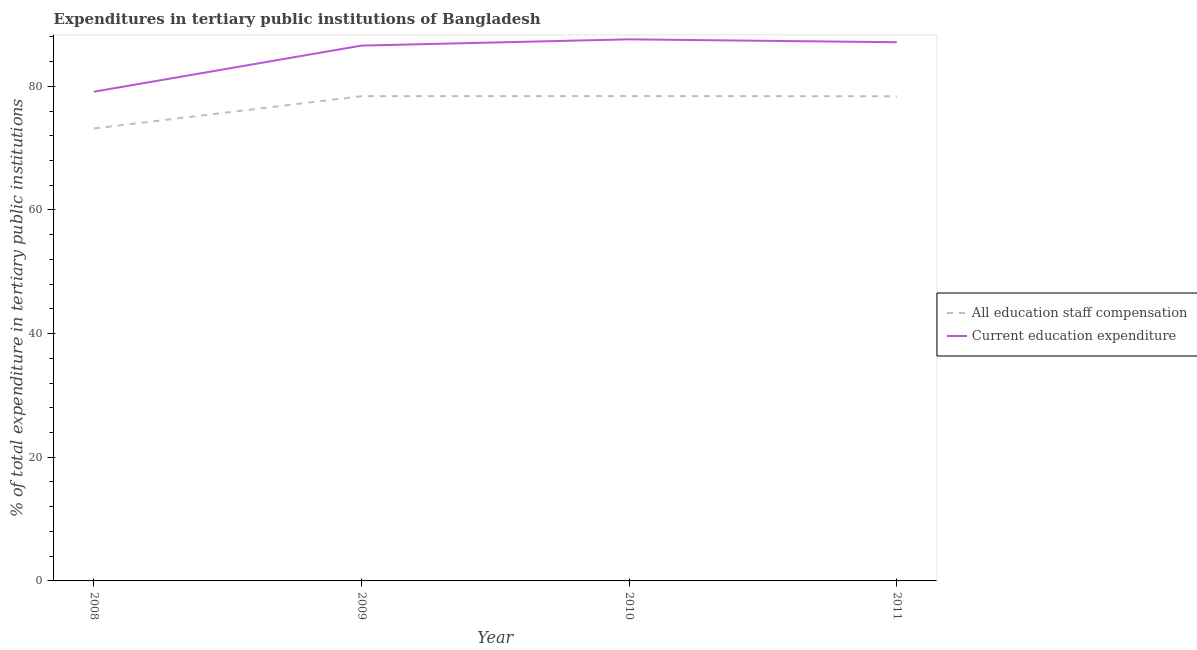How many different coloured lines are there?
Your answer should be very brief. 2. Does the line corresponding to expenditure in staff compensation intersect with the line corresponding to expenditure in education?
Keep it short and to the point. No. What is the expenditure in staff compensation in 2010?
Your answer should be very brief. 78.42. Across all years, what is the maximum expenditure in education?
Provide a succinct answer. 87.59. Across all years, what is the minimum expenditure in education?
Ensure brevity in your answer.  79.12. What is the total expenditure in education in the graph?
Give a very brief answer. 340.41. What is the difference between the expenditure in staff compensation in 2010 and that in 2011?
Your answer should be very brief. 0.04. What is the difference between the expenditure in staff compensation in 2011 and the expenditure in education in 2008?
Ensure brevity in your answer.  -0.74. What is the average expenditure in staff compensation per year?
Offer a very short reply. 77.09. In the year 2010, what is the difference between the expenditure in staff compensation and expenditure in education?
Provide a succinct answer. -9.17. In how many years, is the expenditure in staff compensation greater than 68 %?
Provide a succinct answer. 4. What is the ratio of the expenditure in staff compensation in 2008 to that in 2009?
Your response must be concise. 0.93. Is the expenditure in staff compensation in 2008 less than that in 2010?
Your response must be concise. Yes. What is the difference between the highest and the second highest expenditure in education?
Provide a succinct answer. 0.47. What is the difference between the highest and the lowest expenditure in staff compensation?
Make the answer very short. 5.25. In how many years, is the expenditure in staff compensation greater than the average expenditure in staff compensation taken over all years?
Your response must be concise. 3. Is the expenditure in education strictly greater than the expenditure in staff compensation over the years?
Ensure brevity in your answer.  Yes. How many years are there in the graph?
Your answer should be compact. 4. Does the graph contain grids?
Give a very brief answer. No. How are the legend labels stacked?
Keep it short and to the point. Vertical. What is the title of the graph?
Your answer should be compact. Expenditures in tertiary public institutions of Bangladesh. Does "Number of arrivals" appear as one of the legend labels in the graph?
Offer a terse response. No. What is the label or title of the X-axis?
Give a very brief answer. Year. What is the label or title of the Y-axis?
Provide a succinct answer. % of total expenditure in tertiary public institutions. What is the % of total expenditure in tertiary public institutions in All education staff compensation in 2008?
Provide a short and direct response. 73.17. What is the % of total expenditure in tertiary public institutions in Current education expenditure in 2008?
Make the answer very short. 79.12. What is the % of total expenditure in tertiary public institutions of All education staff compensation in 2009?
Your response must be concise. 78.4. What is the % of total expenditure in tertiary public institutions in Current education expenditure in 2009?
Ensure brevity in your answer.  86.58. What is the % of total expenditure in tertiary public institutions of All education staff compensation in 2010?
Your response must be concise. 78.42. What is the % of total expenditure in tertiary public institutions in Current education expenditure in 2010?
Your answer should be very brief. 87.59. What is the % of total expenditure in tertiary public institutions in All education staff compensation in 2011?
Offer a very short reply. 78.38. What is the % of total expenditure in tertiary public institutions in Current education expenditure in 2011?
Your response must be concise. 87.12. Across all years, what is the maximum % of total expenditure in tertiary public institutions of All education staff compensation?
Ensure brevity in your answer.  78.42. Across all years, what is the maximum % of total expenditure in tertiary public institutions of Current education expenditure?
Provide a succinct answer. 87.59. Across all years, what is the minimum % of total expenditure in tertiary public institutions of All education staff compensation?
Offer a very short reply. 73.17. Across all years, what is the minimum % of total expenditure in tertiary public institutions in Current education expenditure?
Provide a short and direct response. 79.12. What is the total % of total expenditure in tertiary public institutions in All education staff compensation in the graph?
Ensure brevity in your answer.  308.37. What is the total % of total expenditure in tertiary public institutions in Current education expenditure in the graph?
Ensure brevity in your answer.  340.41. What is the difference between the % of total expenditure in tertiary public institutions of All education staff compensation in 2008 and that in 2009?
Give a very brief answer. -5.23. What is the difference between the % of total expenditure in tertiary public institutions in Current education expenditure in 2008 and that in 2009?
Make the answer very short. -7.46. What is the difference between the % of total expenditure in tertiary public institutions in All education staff compensation in 2008 and that in 2010?
Provide a succinct answer. -5.25. What is the difference between the % of total expenditure in tertiary public institutions in Current education expenditure in 2008 and that in 2010?
Offer a very short reply. -8.47. What is the difference between the % of total expenditure in tertiary public institutions in All education staff compensation in 2008 and that in 2011?
Your answer should be very brief. -5.21. What is the difference between the % of total expenditure in tertiary public institutions of Current education expenditure in 2008 and that in 2011?
Your response must be concise. -8. What is the difference between the % of total expenditure in tertiary public institutions of All education staff compensation in 2009 and that in 2010?
Ensure brevity in your answer.  -0.02. What is the difference between the % of total expenditure in tertiary public institutions in Current education expenditure in 2009 and that in 2010?
Keep it short and to the point. -1.01. What is the difference between the % of total expenditure in tertiary public institutions of All education staff compensation in 2009 and that in 2011?
Provide a short and direct response. 0.02. What is the difference between the % of total expenditure in tertiary public institutions in Current education expenditure in 2009 and that in 2011?
Give a very brief answer. -0.54. What is the difference between the % of total expenditure in tertiary public institutions in All education staff compensation in 2010 and that in 2011?
Give a very brief answer. 0.04. What is the difference between the % of total expenditure in tertiary public institutions in Current education expenditure in 2010 and that in 2011?
Your answer should be very brief. 0.47. What is the difference between the % of total expenditure in tertiary public institutions in All education staff compensation in 2008 and the % of total expenditure in tertiary public institutions in Current education expenditure in 2009?
Your response must be concise. -13.41. What is the difference between the % of total expenditure in tertiary public institutions of All education staff compensation in 2008 and the % of total expenditure in tertiary public institutions of Current education expenditure in 2010?
Offer a very short reply. -14.42. What is the difference between the % of total expenditure in tertiary public institutions of All education staff compensation in 2008 and the % of total expenditure in tertiary public institutions of Current education expenditure in 2011?
Make the answer very short. -13.95. What is the difference between the % of total expenditure in tertiary public institutions in All education staff compensation in 2009 and the % of total expenditure in tertiary public institutions in Current education expenditure in 2010?
Ensure brevity in your answer.  -9.2. What is the difference between the % of total expenditure in tertiary public institutions of All education staff compensation in 2009 and the % of total expenditure in tertiary public institutions of Current education expenditure in 2011?
Keep it short and to the point. -8.72. What is the difference between the % of total expenditure in tertiary public institutions in All education staff compensation in 2010 and the % of total expenditure in tertiary public institutions in Current education expenditure in 2011?
Offer a very short reply. -8.7. What is the average % of total expenditure in tertiary public institutions in All education staff compensation per year?
Your answer should be compact. 77.09. What is the average % of total expenditure in tertiary public institutions of Current education expenditure per year?
Keep it short and to the point. 85.1. In the year 2008, what is the difference between the % of total expenditure in tertiary public institutions of All education staff compensation and % of total expenditure in tertiary public institutions of Current education expenditure?
Your response must be concise. -5.95. In the year 2009, what is the difference between the % of total expenditure in tertiary public institutions in All education staff compensation and % of total expenditure in tertiary public institutions in Current education expenditure?
Your answer should be very brief. -8.18. In the year 2010, what is the difference between the % of total expenditure in tertiary public institutions of All education staff compensation and % of total expenditure in tertiary public institutions of Current education expenditure?
Make the answer very short. -9.17. In the year 2011, what is the difference between the % of total expenditure in tertiary public institutions of All education staff compensation and % of total expenditure in tertiary public institutions of Current education expenditure?
Keep it short and to the point. -8.74. What is the ratio of the % of total expenditure in tertiary public institutions in Current education expenditure in 2008 to that in 2009?
Keep it short and to the point. 0.91. What is the ratio of the % of total expenditure in tertiary public institutions in All education staff compensation in 2008 to that in 2010?
Your answer should be compact. 0.93. What is the ratio of the % of total expenditure in tertiary public institutions in Current education expenditure in 2008 to that in 2010?
Give a very brief answer. 0.9. What is the ratio of the % of total expenditure in tertiary public institutions of All education staff compensation in 2008 to that in 2011?
Your response must be concise. 0.93. What is the ratio of the % of total expenditure in tertiary public institutions of Current education expenditure in 2008 to that in 2011?
Keep it short and to the point. 0.91. What is the ratio of the % of total expenditure in tertiary public institutions of All education staff compensation in 2009 to that in 2010?
Your answer should be compact. 1. What is the ratio of the % of total expenditure in tertiary public institutions in Current education expenditure in 2009 to that in 2010?
Make the answer very short. 0.99. What is the ratio of the % of total expenditure in tertiary public institutions in All education staff compensation in 2010 to that in 2011?
Your response must be concise. 1. What is the ratio of the % of total expenditure in tertiary public institutions of Current education expenditure in 2010 to that in 2011?
Your response must be concise. 1.01. What is the difference between the highest and the second highest % of total expenditure in tertiary public institutions of All education staff compensation?
Ensure brevity in your answer.  0.02. What is the difference between the highest and the second highest % of total expenditure in tertiary public institutions in Current education expenditure?
Your response must be concise. 0.47. What is the difference between the highest and the lowest % of total expenditure in tertiary public institutions in All education staff compensation?
Keep it short and to the point. 5.25. What is the difference between the highest and the lowest % of total expenditure in tertiary public institutions of Current education expenditure?
Offer a very short reply. 8.47. 